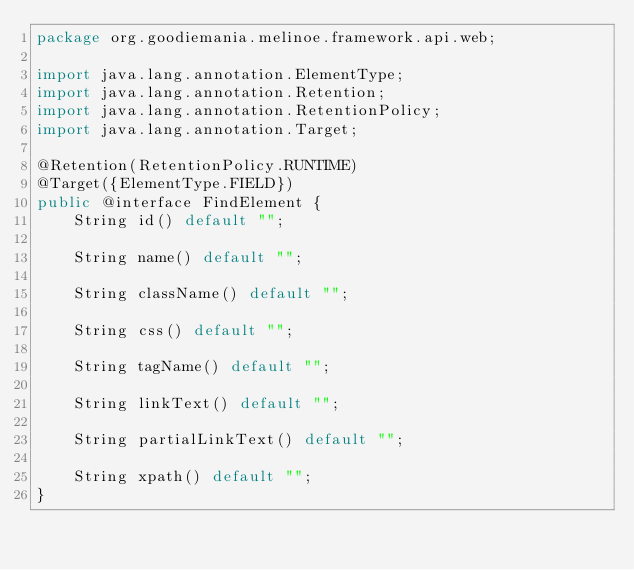<code> <loc_0><loc_0><loc_500><loc_500><_Java_>package org.goodiemania.melinoe.framework.api.web;

import java.lang.annotation.ElementType;
import java.lang.annotation.Retention;
import java.lang.annotation.RetentionPolicy;
import java.lang.annotation.Target;

@Retention(RetentionPolicy.RUNTIME)
@Target({ElementType.FIELD})
public @interface FindElement {
    String id() default "";

    String name() default "";

    String className() default "";

    String css() default "";

    String tagName() default "";

    String linkText() default "";

    String partialLinkText() default "";

    String xpath() default "";
}
</code> 